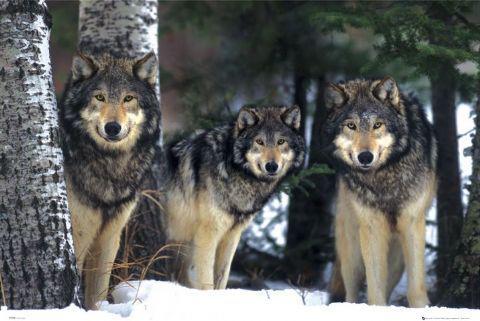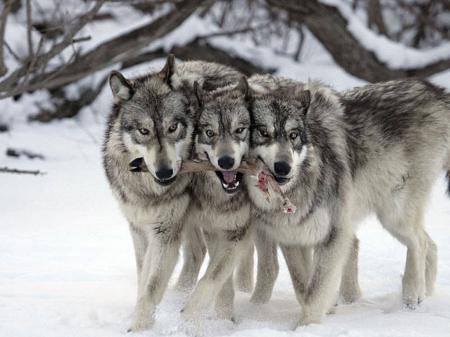The first image is the image on the left, the second image is the image on the right. Assess this claim about the two images: "One image has three wolves without any snow.". Correct or not? Answer yes or no. No. The first image is the image on the left, the second image is the image on the right. Examine the images to the left and right. Is the description "there are 3 wolves huddled close on snowy ground in both pairs" accurate? Answer yes or no. Yes. 